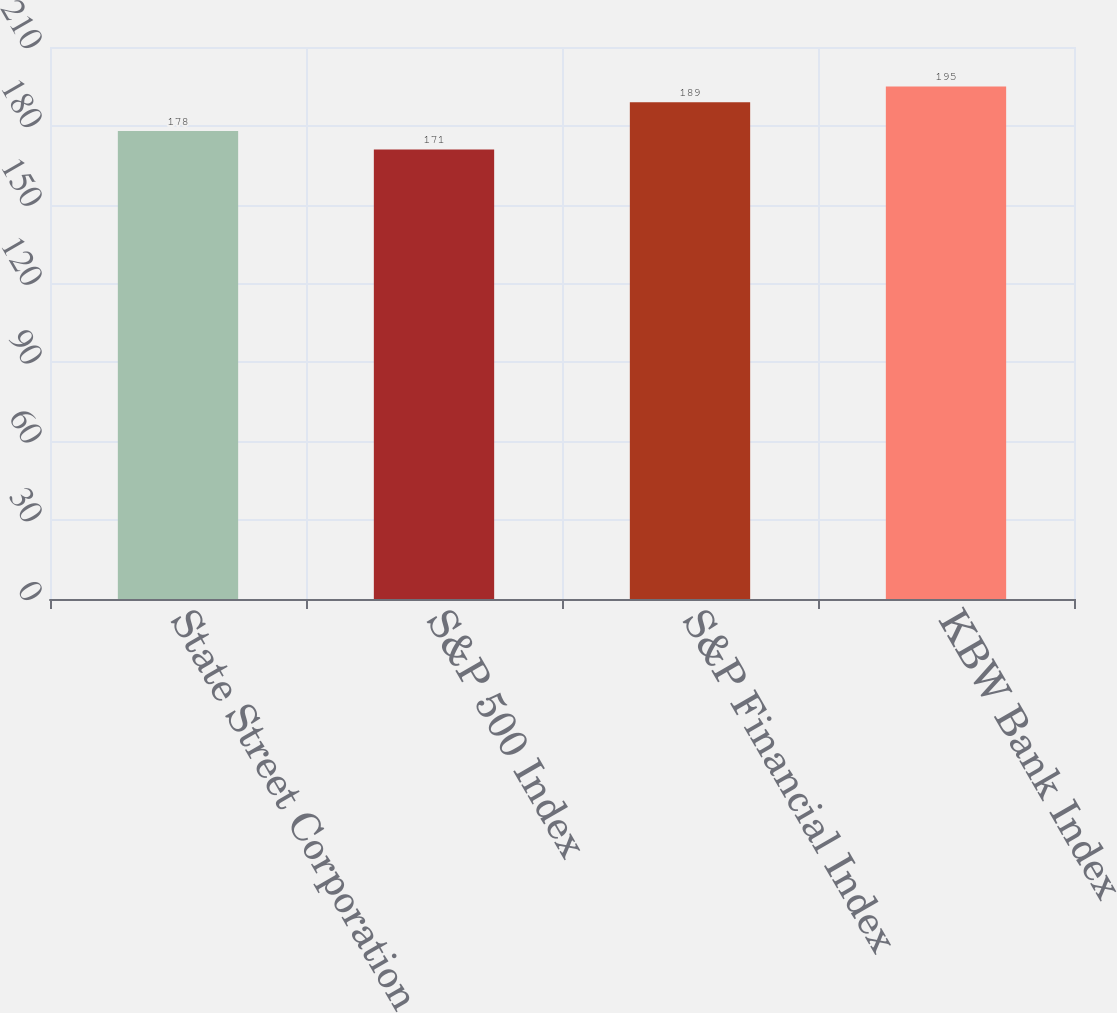<chart> <loc_0><loc_0><loc_500><loc_500><bar_chart><fcel>State Street Corporation<fcel>S&P 500 Index<fcel>S&P Financial Index<fcel>KBW Bank Index<nl><fcel>178<fcel>171<fcel>189<fcel>195<nl></chart> 